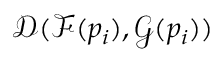Convert formula to latex. <formula><loc_0><loc_0><loc_500><loc_500>\mathcal { D } ( \mathcal { F } ( p _ { i } ) , \mathcal { G } ( p _ { i } ) )</formula> 